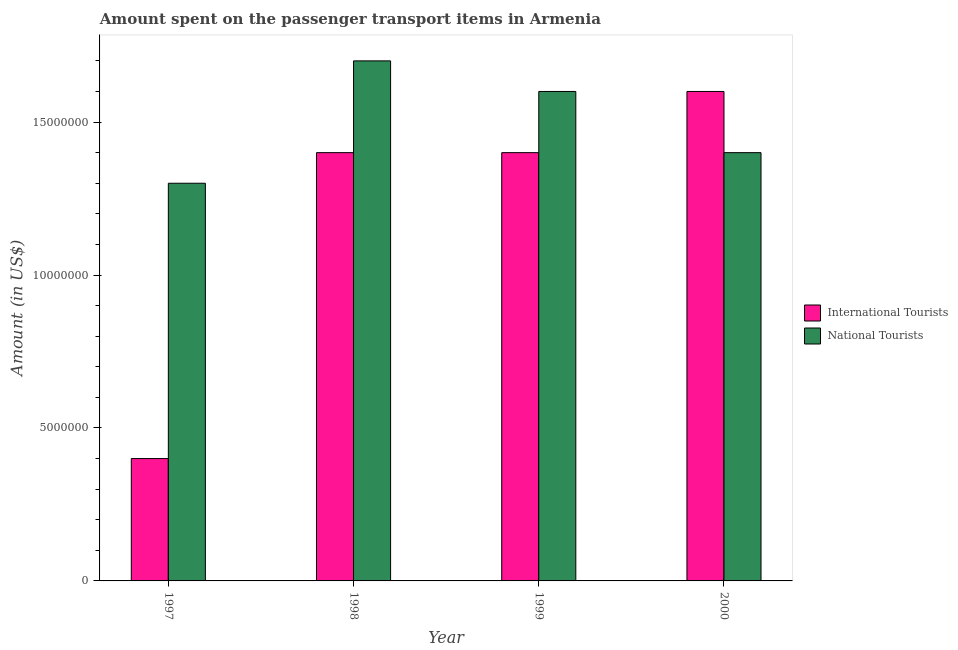How many groups of bars are there?
Your answer should be very brief. 4. How many bars are there on the 3rd tick from the left?
Offer a very short reply. 2. What is the label of the 4th group of bars from the left?
Offer a terse response. 2000. What is the amount spent on transport items of international tourists in 1999?
Offer a terse response. 1.40e+07. Across all years, what is the maximum amount spent on transport items of national tourists?
Provide a succinct answer. 1.70e+07. Across all years, what is the minimum amount spent on transport items of national tourists?
Your answer should be very brief. 1.30e+07. In which year was the amount spent on transport items of international tourists minimum?
Offer a terse response. 1997. What is the total amount spent on transport items of national tourists in the graph?
Your answer should be very brief. 6.00e+07. What is the difference between the amount spent on transport items of national tourists in 1999 and that in 2000?
Your response must be concise. 2.00e+06. What is the difference between the amount spent on transport items of national tourists in 1997 and the amount spent on transport items of international tourists in 1998?
Give a very brief answer. -4.00e+06. What is the average amount spent on transport items of national tourists per year?
Your answer should be compact. 1.50e+07. In the year 1997, what is the difference between the amount spent on transport items of national tourists and amount spent on transport items of international tourists?
Your answer should be very brief. 0. What is the ratio of the amount spent on transport items of international tourists in 1998 to that in 2000?
Provide a succinct answer. 0.88. Is the amount spent on transport items of international tourists in 1997 less than that in 1999?
Your answer should be compact. Yes. Is the difference between the amount spent on transport items of international tourists in 1999 and 2000 greater than the difference between the amount spent on transport items of national tourists in 1999 and 2000?
Your answer should be very brief. No. What is the difference between the highest and the second highest amount spent on transport items of international tourists?
Provide a short and direct response. 2.00e+06. What is the difference between the highest and the lowest amount spent on transport items of national tourists?
Your answer should be compact. 4.00e+06. In how many years, is the amount spent on transport items of international tourists greater than the average amount spent on transport items of international tourists taken over all years?
Provide a short and direct response. 3. Is the sum of the amount spent on transport items of international tourists in 1997 and 1999 greater than the maximum amount spent on transport items of national tourists across all years?
Offer a very short reply. Yes. What does the 1st bar from the left in 2000 represents?
Your answer should be compact. International Tourists. What does the 2nd bar from the right in 1999 represents?
Your answer should be very brief. International Tourists. Are all the bars in the graph horizontal?
Give a very brief answer. No. What is the difference between two consecutive major ticks on the Y-axis?
Your response must be concise. 5.00e+06. Are the values on the major ticks of Y-axis written in scientific E-notation?
Provide a short and direct response. No. Does the graph contain any zero values?
Ensure brevity in your answer.  No. Does the graph contain grids?
Provide a succinct answer. No. Where does the legend appear in the graph?
Give a very brief answer. Center right. How are the legend labels stacked?
Keep it short and to the point. Vertical. What is the title of the graph?
Offer a terse response. Amount spent on the passenger transport items in Armenia. What is the label or title of the X-axis?
Your response must be concise. Year. What is the label or title of the Y-axis?
Your response must be concise. Amount (in US$). What is the Amount (in US$) of National Tourists in 1997?
Your answer should be very brief. 1.30e+07. What is the Amount (in US$) in International Tourists in 1998?
Provide a short and direct response. 1.40e+07. What is the Amount (in US$) in National Tourists in 1998?
Your answer should be compact. 1.70e+07. What is the Amount (in US$) of International Tourists in 1999?
Keep it short and to the point. 1.40e+07. What is the Amount (in US$) in National Tourists in 1999?
Your answer should be compact. 1.60e+07. What is the Amount (in US$) in International Tourists in 2000?
Give a very brief answer. 1.60e+07. What is the Amount (in US$) of National Tourists in 2000?
Offer a terse response. 1.40e+07. Across all years, what is the maximum Amount (in US$) of International Tourists?
Ensure brevity in your answer.  1.60e+07. Across all years, what is the maximum Amount (in US$) in National Tourists?
Make the answer very short. 1.70e+07. Across all years, what is the minimum Amount (in US$) in International Tourists?
Your answer should be very brief. 4.00e+06. Across all years, what is the minimum Amount (in US$) of National Tourists?
Keep it short and to the point. 1.30e+07. What is the total Amount (in US$) of International Tourists in the graph?
Keep it short and to the point. 4.80e+07. What is the total Amount (in US$) of National Tourists in the graph?
Your answer should be compact. 6.00e+07. What is the difference between the Amount (in US$) in International Tourists in 1997 and that in 1998?
Make the answer very short. -1.00e+07. What is the difference between the Amount (in US$) in National Tourists in 1997 and that in 1998?
Make the answer very short. -4.00e+06. What is the difference between the Amount (in US$) in International Tourists in 1997 and that in 1999?
Offer a very short reply. -1.00e+07. What is the difference between the Amount (in US$) in National Tourists in 1997 and that in 1999?
Provide a short and direct response. -3.00e+06. What is the difference between the Amount (in US$) of International Tourists in 1997 and that in 2000?
Make the answer very short. -1.20e+07. What is the difference between the Amount (in US$) in International Tourists in 1998 and that in 1999?
Your response must be concise. 0. What is the difference between the Amount (in US$) of National Tourists in 1998 and that in 1999?
Offer a terse response. 1.00e+06. What is the difference between the Amount (in US$) in International Tourists in 1998 and that in 2000?
Keep it short and to the point. -2.00e+06. What is the difference between the Amount (in US$) of National Tourists in 1998 and that in 2000?
Ensure brevity in your answer.  3.00e+06. What is the difference between the Amount (in US$) in International Tourists in 1999 and that in 2000?
Your answer should be compact. -2.00e+06. What is the difference between the Amount (in US$) in National Tourists in 1999 and that in 2000?
Your response must be concise. 2.00e+06. What is the difference between the Amount (in US$) of International Tourists in 1997 and the Amount (in US$) of National Tourists in 1998?
Your answer should be very brief. -1.30e+07. What is the difference between the Amount (in US$) in International Tourists in 1997 and the Amount (in US$) in National Tourists in 1999?
Provide a succinct answer. -1.20e+07. What is the difference between the Amount (in US$) of International Tourists in 1997 and the Amount (in US$) of National Tourists in 2000?
Keep it short and to the point. -1.00e+07. What is the difference between the Amount (in US$) of International Tourists in 1998 and the Amount (in US$) of National Tourists in 1999?
Your response must be concise. -2.00e+06. What is the difference between the Amount (in US$) of International Tourists in 1998 and the Amount (in US$) of National Tourists in 2000?
Offer a very short reply. 0. What is the average Amount (in US$) of National Tourists per year?
Offer a terse response. 1.50e+07. In the year 1997, what is the difference between the Amount (in US$) of International Tourists and Amount (in US$) of National Tourists?
Offer a very short reply. -9.00e+06. In the year 1999, what is the difference between the Amount (in US$) in International Tourists and Amount (in US$) in National Tourists?
Keep it short and to the point. -2.00e+06. What is the ratio of the Amount (in US$) in International Tourists in 1997 to that in 1998?
Keep it short and to the point. 0.29. What is the ratio of the Amount (in US$) in National Tourists in 1997 to that in 1998?
Your response must be concise. 0.76. What is the ratio of the Amount (in US$) in International Tourists in 1997 to that in 1999?
Keep it short and to the point. 0.29. What is the ratio of the Amount (in US$) of National Tourists in 1997 to that in 1999?
Offer a terse response. 0.81. What is the ratio of the Amount (in US$) of International Tourists in 1997 to that in 2000?
Keep it short and to the point. 0.25. What is the ratio of the Amount (in US$) of International Tourists in 1998 to that in 2000?
Your response must be concise. 0.88. What is the ratio of the Amount (in US$) of National Tourists in 1998 to that in 2000?
Your response must be concise. 1.21. What is the difference between the highest and the second highest Amount (in US$) of International Tourists?
Provide a short and direct response. 2.00e+06. What is the difference between the highest and the second highest Amount (in US$) of National Tourists?
Your answer should be very brief. 1.00e+06. What is the difference between the highest and the lowest Amount (in US$) in International Tourists?
Make the answer very short. 1.20e+07. 